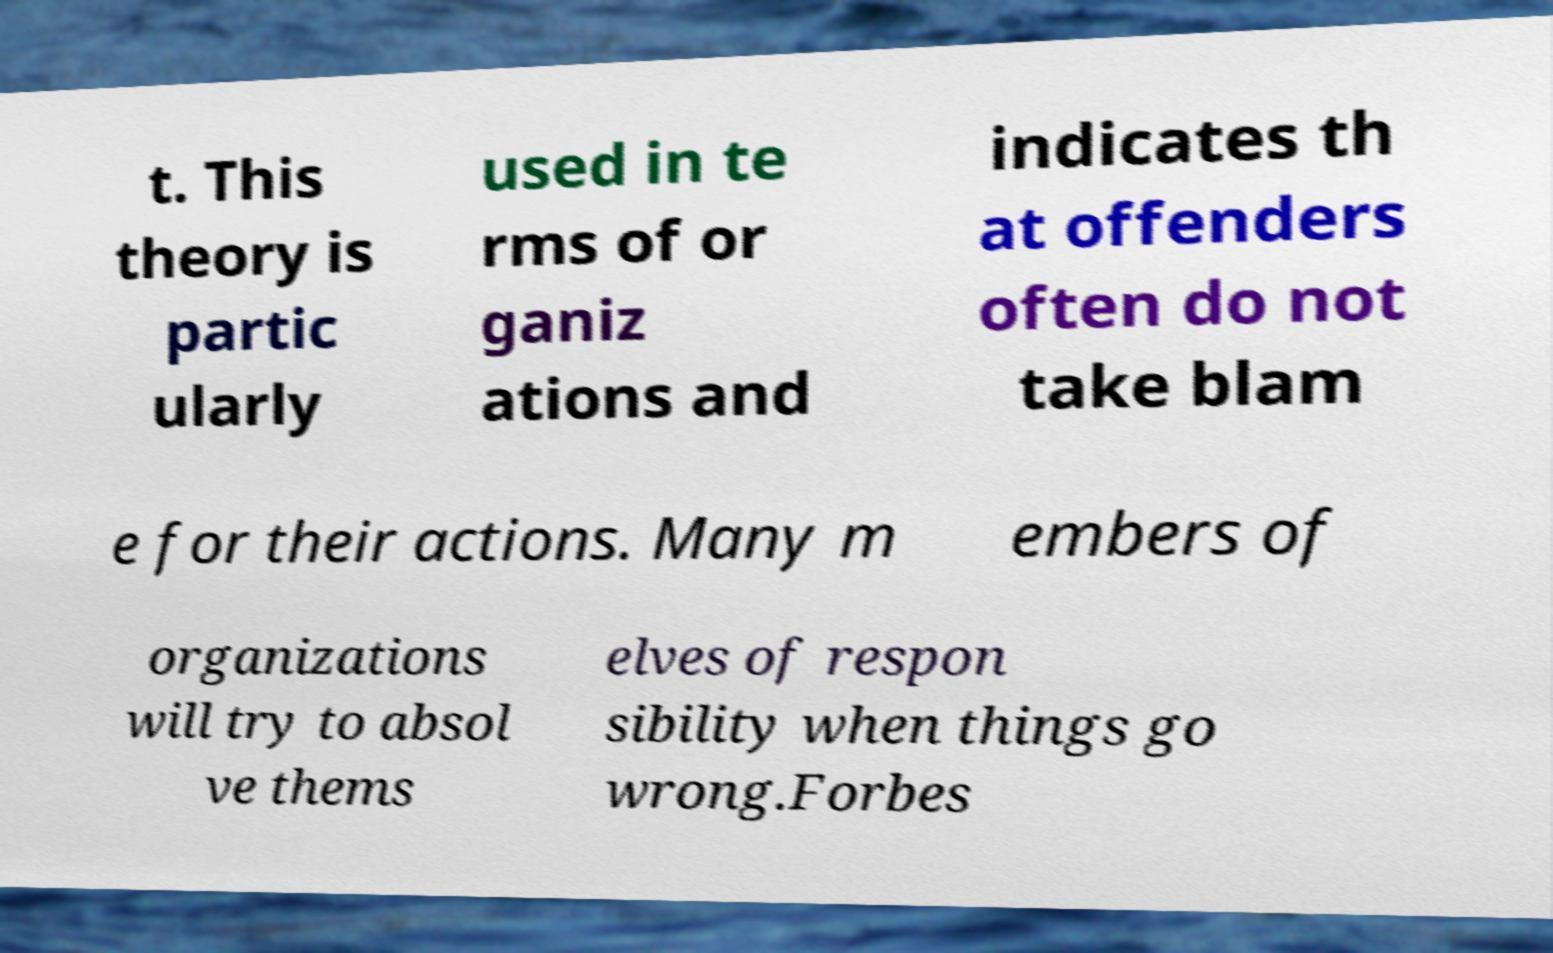Please read and relay the text visible in this image. What does it say? t. This theory is partic ularly used in te rms of or ganiz ations and indicates th at offenders often do not take blam e for their actions. Many m embers of organizations will try to absol ve thems elves of respon sibility when things go wrong.Forbes 